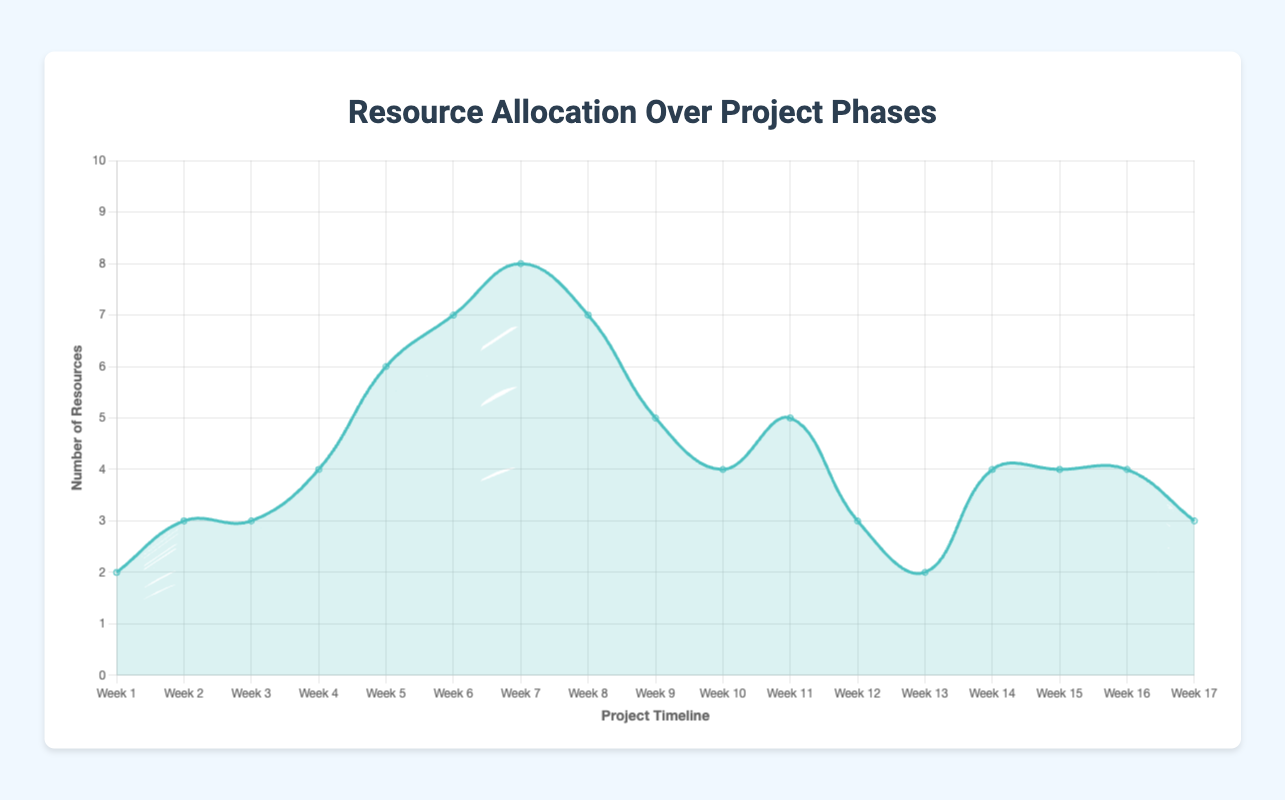What is the title of the chart? The title is located at the top of the chart. It summarizes what the chart is about.
Answer: Resource Allocation Over Project Phases How many weeks are shown in the chart? To find this, count the labels along the x-axis.
Answer: 17 During which week in the Development phase was the number of resources the highest? Look at the weeks labeled for the Development phase and find the week with the highest peak.
Answer: Week 7 How does the resource allocation in the Deployment phase compare to the Testing phase? Compare the y-axis values of the Deployment phase (weeks 12 and 13) and the Testing phase (weeks 9 to 11).
Answer: The Deployment phase has fewer resources What is the average number of resources allocated in the TensorFlow Optimization phase? Sum the resources for weeks 14 to 17 and divide by the number of weeks (4). Calculation is (4 + 4 + 4 + 3)/4 = 3.75.
Answer: 3.75 Which phase had a constant amount of resources for more than one week? Look through the data and identify any phase where the resources do not change for consecutive weeks.
Answer: TensorFlow Optimization phase (weeks 14, 15, and 16) What was the total number of resources allocated during the Planning phase? Sum the resources for weeks 1 to 3. Calculation is 2 + 3 + 3 = 8.
Answer: 8 Between which two consecutive weeks was the largest increase in resource allocation? Compare the difference in resources allocated for each consecutive pair of weeks and identify the largest change. Looking through the data, the largest increase is between week 3 and week 4 (3 to 4, an increase of 1).
Answer: Weeks 3 and 4 When did the Optimization with TensorFlow phase start in terms of weeks, and with how many resources? Determine the starting week for the Optimization with TensorFlow phase and the number of resources allocated at the beginning.
Answer: Week 14, 4 resources What is the trend in resource allocation during the Testing phase? Examine the resource values from weeks 9 to 11 and describe whether they increase, decrease, or stay constant.
Answer: The trend is fluctuating, starting at 5, dropping to 4, then rising back to 5 